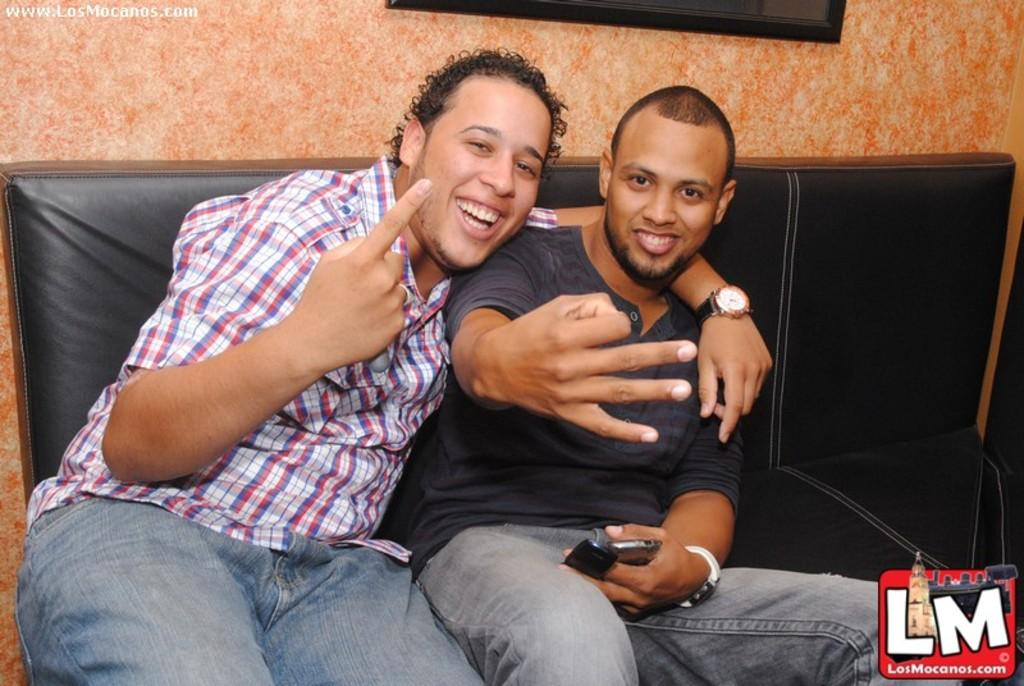How many people are in the image? There are two persons in the image. What are the two persons doing in the image? The two persons are sitting on a couch. Can you describe what one of the persons is holding? One person is holding a mobile. What type of sweater is the person wearing in the image? There is no sweater mentioned or visible in the image. How does the sun affect the scene in the image? The image does not show any outdoor elements or the presence of the sun, so its effect on the scene cannot be determined. 